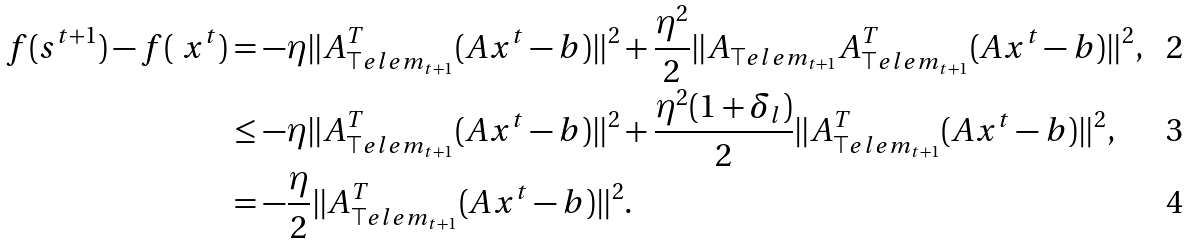Convert formula to latex. <formula><loc_0><loc_0><loc_500><loc_500>f ( s ^ { t + 1 } ) - f ( \ x ^ { t } ) & = - \eta \| A ^ { T } _ { \top e l e m _ { t + 1 } } ( A x ^ { t } - b ) \| ^ { 2 } + \frac { \eta ^ { 2 } } { 2 } \| A _ { \top e l e m _ { t + 1 } } A ^ { T } _ { \top e l e m _ { t + 1 } } ( A x ^ { t } - b ) \| ^ { 2 } , \\ & \leq - \eta \| A ^ { T } _ { \top e l e m _ { t + 1 } } ( A x ^ { t } - b ) \| ^ { 2 } + \frac { \eta ^ { 2 } ( 1 + \delta _ { l } ) } { 2 } \| A ^ { T } _ { \top e l e m _ { t + 1 } } ( A x ^ { t } - b ) \| ^ { 2 } , \\ & = - \frac { \eta } { 2 } \| A ^ { T } _ { \top e l e m _ { t + 1 } } ( A x ^ { t } - b ) \| ^ { 2 } .</formula> 